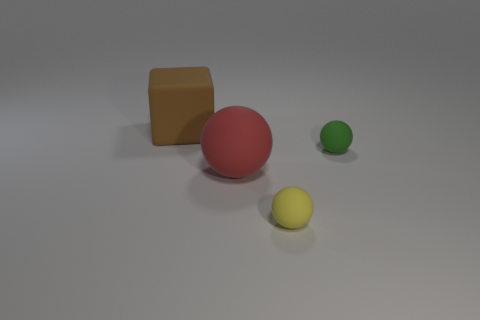How many big objects are either blue things or red rubber things?
Offer a terse response. 1. What size is the cube?
Offer a terse response. Large. Are there more things that are behind the large red rubber ball than small yellow matte objects?
Offer a terse response. Yes. Is the number of yellow rubber objects to the right of the yellow ball the same as the number of tiny yellow balls that are in front of the brown object?
Your response must be concise. No. There is a object that is both to the left of the yellow ball and in front of the large brown thing; what is its color?
Offer a terse response. Red. Are there more things in front of the big red object than big cubes that are right of the yellow sphere?
Provide a short and direct response. Yes. Does the green matte ball to the right of the yellow matte ball have the same size as the red rubber sphere?
Offer a terse response. No. What number of green spheres are in front of the large rubber thing in front of the small rubber thing that is right of the yellow thing?
Offer a terse response. 0. There is a matte thing that is behind the large red ball and left of the tiny green matte sphere; what is its size?
Provide a succinct answer. Large. What number of other things are there of the same shape as the brown object?
Provide a succinct answer. 0. 